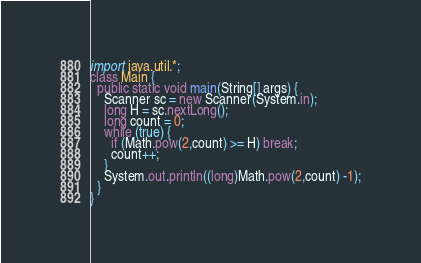Convert code to text. <code><loc_0><loc_0><loc_500><loc_500><_Java_>import java.util.*;
class Main {
  public static void main(String[] args) {
    Scanner sc = new Scanner(System.in);
    long H = sc.nextLong();
    long count = 0;
    while (true) {
      if (Math.pow(2,count) >= H) break;
      count++;
    }
    System.out.println((long)Math.pow(2,count) -1);
  }
}</code> 